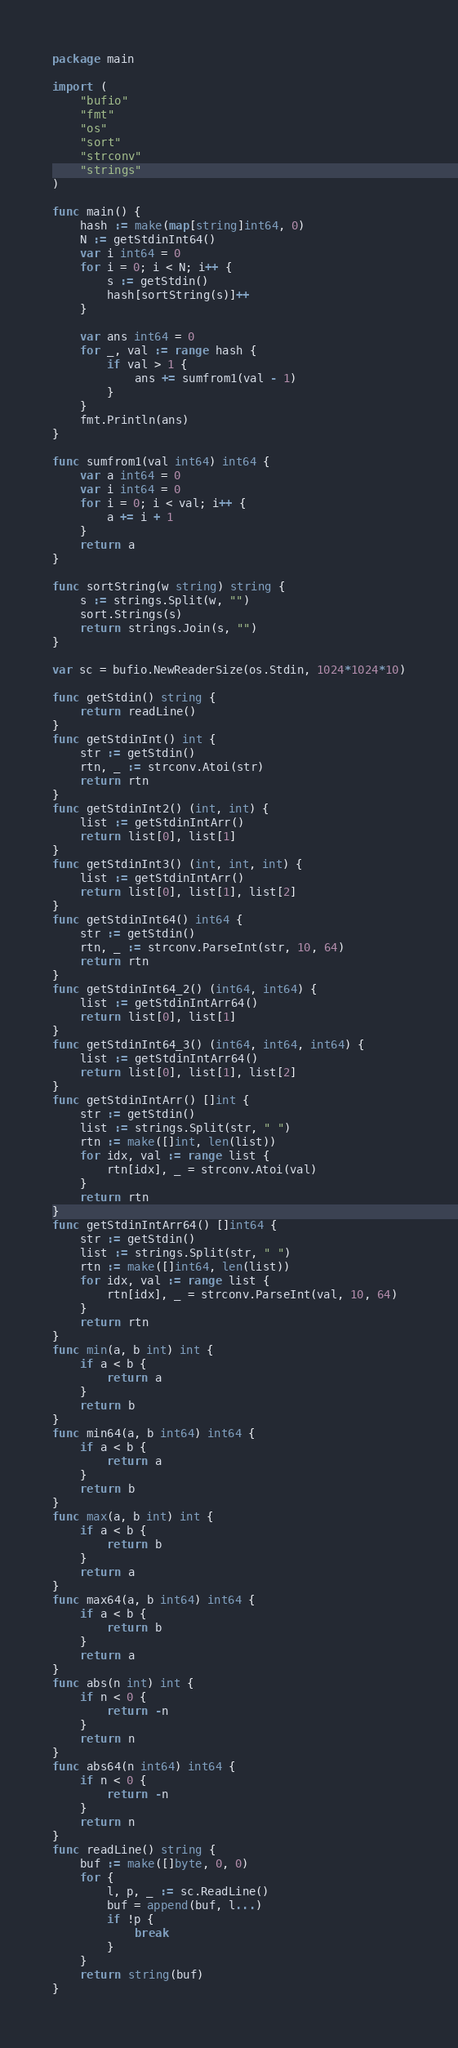Convert code to text. <code><loc_0><loc_0><loc_500><loc_500><_Go_>package main

import (
	"bufio"
	"fmt"
	"os"
	"sort"
	"strconv"
	"strings"
)

func main() {
	hash := make(map[string]int64, 0)
	N := getStdinInt64()
	var i int64 = 0
	for i = 0; i < N; i++ {
		s := getStdin()
		hash[sortString(s)]++
	}

	var ans int64 = 0
	for _, val := range hash {
		if val > 1 {
			ans += sumfrom1(val - 1)
		}
	}
	fmt.Println(ans)
}

func sumfrom1(val int64) int64 {
	var a int64 = 0
	var i int64 = 0
	for i = 0; i < val; i++ {
		a += i + 1
	}
	return a
}

func sortString(w string) string {
	s := strings.Split(w, "")
	sort.Strings(s)
	return strings.Join(s, "")
}

var sc = bufio.NewReaderSize(os.Stdin, 1024*1024*10)

func getStdin() string {
	return readLine()
}
func getStdinInt() int {
	str := getStdin()
	rtn, _ := strconv.Atoi(str)
	return rtn
}
func getStdinInt2() (int, int) {
	list := getStdinIntArr()
	return list[0], list[1]
}
func getStdinInt3() (int, int, int) {
	list := getStdinIntArr()
	return list[0], list[1], list[2]
}
func getStdinInt64() int64 {
	str := getStdin()
	rtn, _ := strconv.ParseInt(str, 10, 64)
	return rtn
}
func getStdinInt64_2() (int64, int64) {
	list := getStdinIntArr64()
	return list[0], list[1]
}
func getStdinInt64_3() (int64, int64, int64) {
	list := getStdinIntArr64()
	return list[0], list[1], list[2]
}
func getStdinIntArr() []int {
	str := getStdin()
	list := strings.Split(str, " ")
	rtn := make([]int, len(list))
	for idx, val := range list {
		rtn[idx], _ = strconv.Atoi(val)
	}
	return rtn
}
func getStdinIntArr64() []int64 {
	str := getStdin()
	list := strings.Split(str, " ")
	rtn := make([]int64, len(list))
	for idx, val := range list {
		rtn[idx], _ = strconv.ParseInt(val, 10, 64)
	}
	return rtn
}
func min(a, b int) int {
	if a < b {
		return a
	}
	return b
}
func min64(a, b int64) int64 {
	if a < b {
		return a
	}
	return b
}
func max(a, b int) int {
	if a < b {
		return b
	}
	return a
}
func max64(a, b int64) int64 {
	if a < b {
		return b
	}
	return a
}
func abs(n int) int {
	if n < 0 {
		return -n
	}
	return n
}
func abs64(n int64) int64 {
	if n < 0 {
		return -n
	}
	return n
}
func readLine() string {
	buf := make([]byte, 0, 0)
	for {
		l, p, _ := sc.ReadLine()
		buf = append(buf, l...)
		if !p {
			break
		}
	}
	return string(buf)
}
</code> 